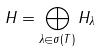Convert formula to latex. <formula><loc_0><loc_0><loc_500><loc_500>H = \bigoplus _ { \lambda \in \sigma ( T ) } H _ { \lambda }</formula> 